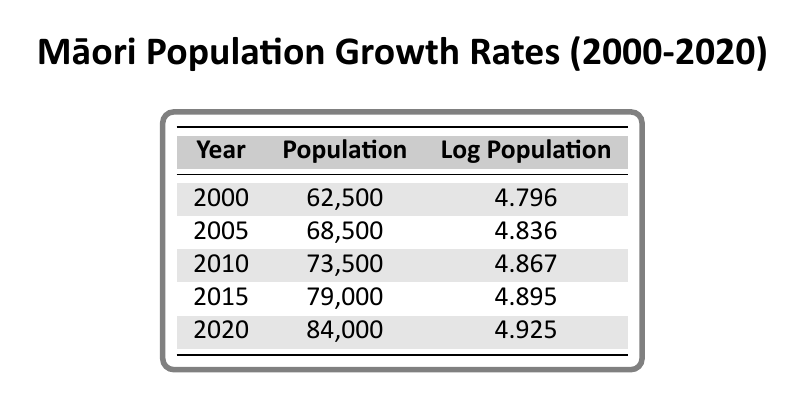What's the population of the Māori community in 2010? The table shows the population for each year listed. For the year 2010, the population is directly indicated as 73,500.
Answer: 73,500 What is the log population value for the year 2005? Referring to the table, the log population value for 2005 is clearly stated as 4.836.
Answer: 4.836 Which year has the highest population, and what is that population? By examining the population values for each year, 2020 has the highest population of 84,000.
Answer: 2020, 84,000 What is the difference in population between 2000 and 2020? The populations for 2000 and 2020 are 62,500 and 84,000, respectively. Calculating the difference: 84,000 - 62,500 = 21,500.
Answer: 21,500 Is the population growth rate from 2000 to 2005 greater than from 2015 to 2020? Firstly, calculate the growth from 2000 to 2005: 68,500 - 62,500 = 6,000. Then from 2015 to 2020: 84,000 - 79,000 = 5,000. Since 6,000 > 5,000, the statement is correct.
Answer: Yes What is the average log population from 2000 to 2020? The log population values are: 4.796, 4.836, 4.867, 4.895, and 4.925. Adding them gives 24.319. Dividing by the number of years (5): 24.319 / 5 = 4.8638, rounded to 4.864.
Answer: 4.864 In which year was the population less than 70,000? The years with populations below 70,000 are 2000 (62,500) and 2005 (68,500). Thus, both 2000 and 2005 have populations less than 70,000.
Answer: 2000, 2005 What was the increase in log population from 2010 to 2020? The log population for 2010 is 4.867 and for 2020 is 4.925. Subtracting these gives 4.925 - 4.867 = 0.058.
Answer: 0.058 Is the population in 2015 greater than the average population from 2000 to 2010? The average for 2000 (62,500), 2005 (68,500), and 2010 (73,500) is (62,500 + 68,500 + 73,500) / 3 = 68,500. Since 79,000 (2015) is greater than 68,500, the statement is true.
Answer: Yes 